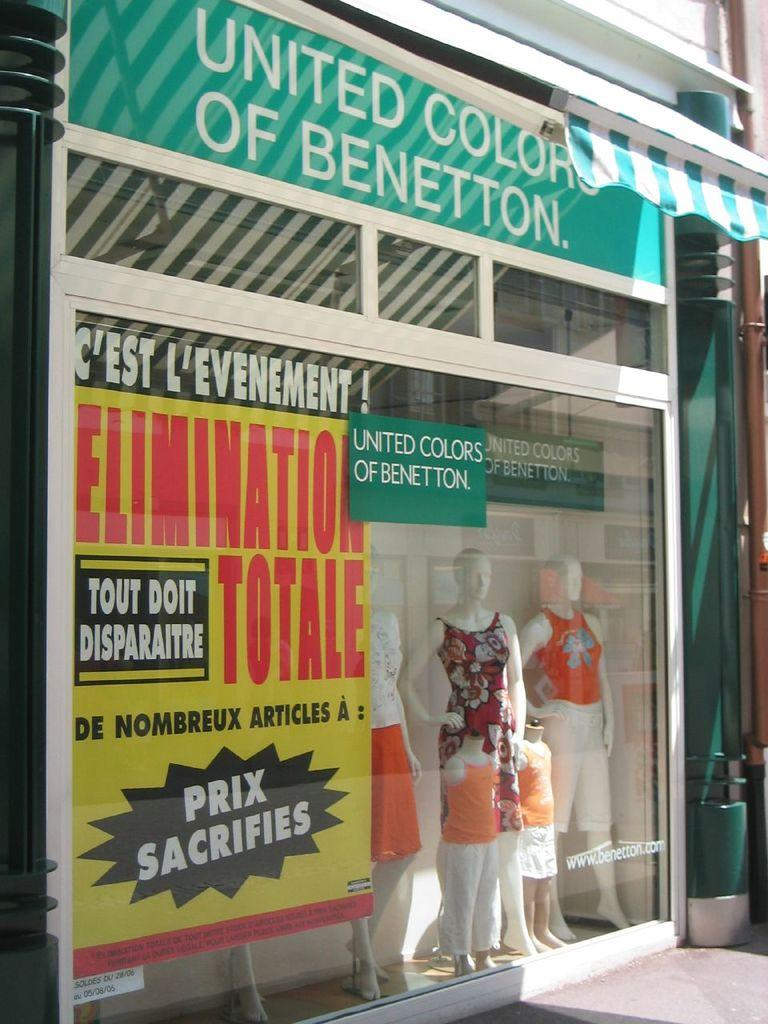What type of establishment is depicted in the image? There is a store in the image. What can be seen on the walls or windows of the store? There is a poster in the image. What material are the boards made of in the image? There are boards in the image, but the material is not specified. What type of entrance is visible in the image? There are glass doors in the image. What type of items are displayed in the store? There are clothes on mannequins in the image. What other objects can be seen in the store? There are other objects in the image, but their specific nature is not mentioned. What type of card is the grandfather holding in the image? There is no grandfather or card present in the image. 